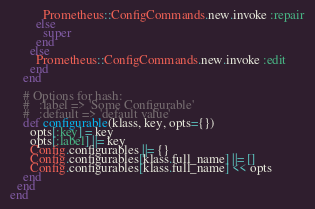Convert code to text. <code><loc_0><loc_0><loc_500><loc_500><_Ruby_>          Prometheus::ConfigCommands.new.invoke :repair
        else
          super
        end
      else
        Prometheus::ConfigCommands.new.invoke :edit
      end
    end

    # Options for hash:
    #   :label => 'Some Configurable'
    #   :default => 'default value'
    def configurable(klass, key, opts={})
      opts[:key] = key
      opts[:label] ||= key
      Config.configurables ||= {}
      Config.configurables[klass.full_name] ||= []
      Config.configurables[klass.full_name] << opts
    end
  end
end
</code> 